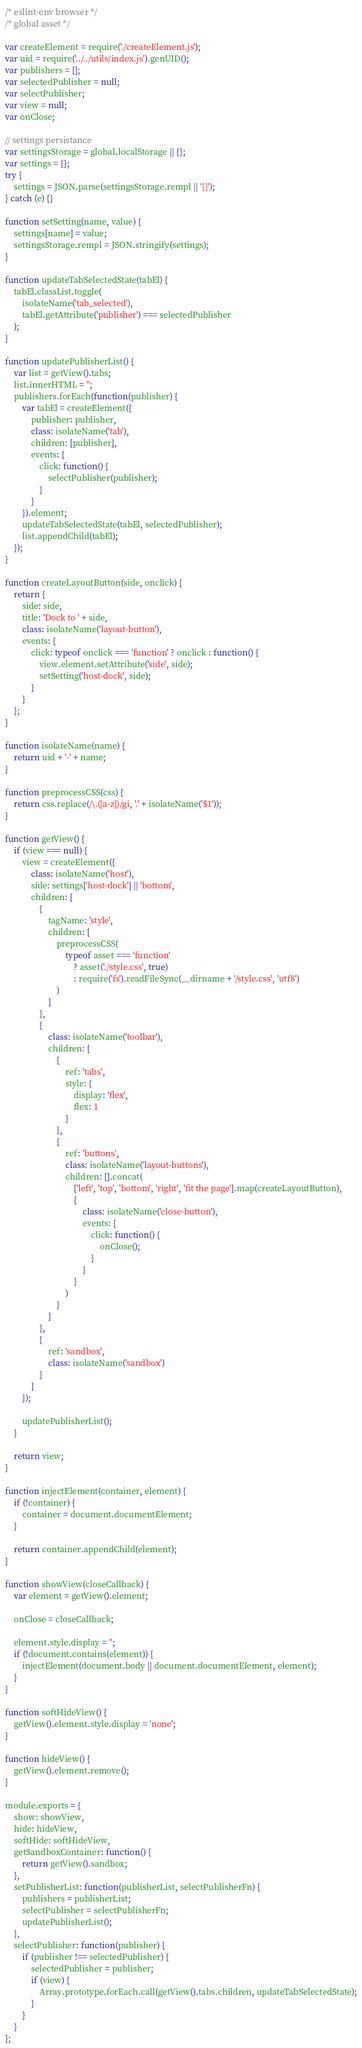<code> <loc_0><loc_0><loc_500><loc_500><_JavaScript_>/* eslint-env browser */
/* global asset */

var createElement = require('./createElement.js');
var uid = require('../../utils/index.js').genUID();
var publishers = [];
var selectedPublisher = null;
var selectPublisher;
var view = null;
var onClose;

// settings persistance
var settingsStorage = global.localStorage || {};
var settings = {};
try {
    settings = JSON.parse(settingsStorage.rempl || '{}');
} catch (e) {}

function setSetting(name, value) {
    settings[name] = value;
    settingsStorage.rempl = JSON.stringify(settings);
}

function updateTabSelectedState(tabEl) {
    tabEl.classList.toggle(
        isolateName('tab_selected'),
        tabEl.getAttribute('publisher') === selectedPublisher
    );
}

function updatePublisherList() {
    var list = getView().tabs;
    list.innerHTML = '';
    publishers.forEach(function(publisher) {
        var tabEl = createElement({
            publisher: publisher,
            class: isolateName('tab'),
            children: [publisher],
            events: {
                click: function() {
                    selectPublisher(publisher);
                }
            }
        }).element;
        updateTabSelectedState(tabEl, selectedPublisher);
        list.appendChild(tabEl);
    });
}

function createLayoutButton(side, onclick) {
    return {
        side: side,
        title: 'Dock to ' + side,
        class: isolateName('layout-button'),
        events: {
            click: typeof onclick === 'function' ? onclick : function() {
                view.element.setAttribute('side', side);
                setSetting('host-dock', side);
            }
        }
    };
}

function isolateName(name) {
    return uid + '-' + name;
}

function preprocessCSS(css) {
    return css.replace(/\.([a-z])/gi, '.' + isolateName('$1'));
}

function getView() {
    if (view === null) {
        view = createElement({
            class: isolateName('host'),
            side: settings['host-dock'] || 'bottom',
            children: [
                {
                    tagName: 'style',
                    children: [
                        preprocessCSS(
                            typeof asset === 'function'
                                ? asset('./style.css', true)
                                : require('fs').readFileSync(__dirname + '/style.css', 'utf8')
                        )
                    ]
                },
                {
                    class: isolateName('toolbar'),
                    children: [
                        {
                            ref: 'tabs',
                            style: {
                                display: 'flex',
                                flex: 1
                            }
                        },
                        {
                            ref: 'buttons',
                            class: isolateName('layout-buttons'),
                            children: [].concat(
                                ['left', 'top', 'bottom', 'right', 'fit the page'].map(createLayoutButton),
                                {
                                    class: isolateName('close-button'),
                                    events: {
                                        click: function() {
                                            onClose();
                                        }
                                    }
                                }
                            )
                        }
                    ]
                },
                {
                    ref: 'sandbox',
                    class: isolateName('sandbox')
                }
            ]
        });

        updatePublisherList();
    }

    return view;
}

function injectElement(container, element) {
    if (!container) {
        container = document.documentElement;
    }

    return container.appendChild(element);
}

function showView(closeCallback) {
    var element = getView().element;

    onClose = closeCallback;

    element.style.display = '';
    if (!document.contains(element)) {
        injectElement(document.body || document.documentElement, element);
    }
}

function softHideView() {
    getView().element.style.display = 'none';
}

function hideView() {
    getView().element.remove();
}

module.exports = {
    show: showView,
    hide: hideView,
    softHide: softHideView,
    getSandboxContainer: function() {
        return getView().sandbox;
    },
    setPublisherList: function(publisherList, selectPublisherFn) {
        publishers = publisherList;
        selectPublisher = selectPublisherFn;
        updatePublisherList();
    },
    selectPublisher: function(publisher) {
        if (publisher !== selectedPublisher) {
            selectedPublisher = publisher;
            if (view) {
                Array.prototype.forEach.call(getView().tabs.children, updateTabSelectedState);
            }
        }
    }
};
</code> 